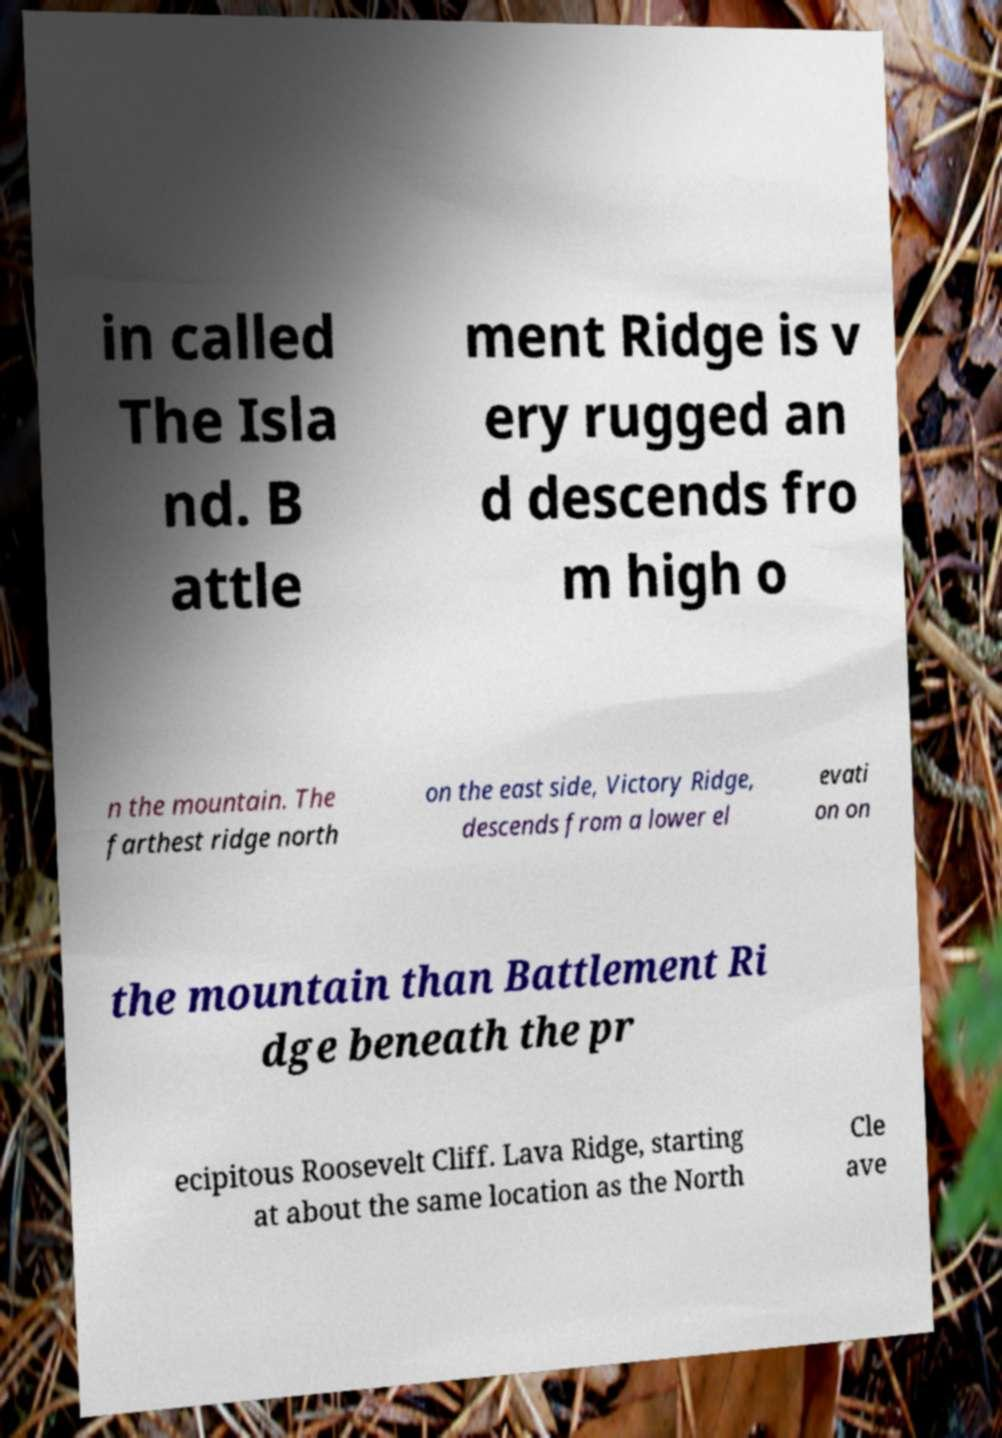Please read and relay the text visible in this image. What does it say? in called The Isla nd. B attle ment Ridge is v ery rugged an d descends fro m high o n the mountain. The farthest ridge north on the east side, Victory Ridge, descends from a lower el evati on on the mountain than Battlement Ri dge beneath the pr ecipitous Roosevelt Cliff. Lava Ridge, starting at about the same location as the North Cle ave 